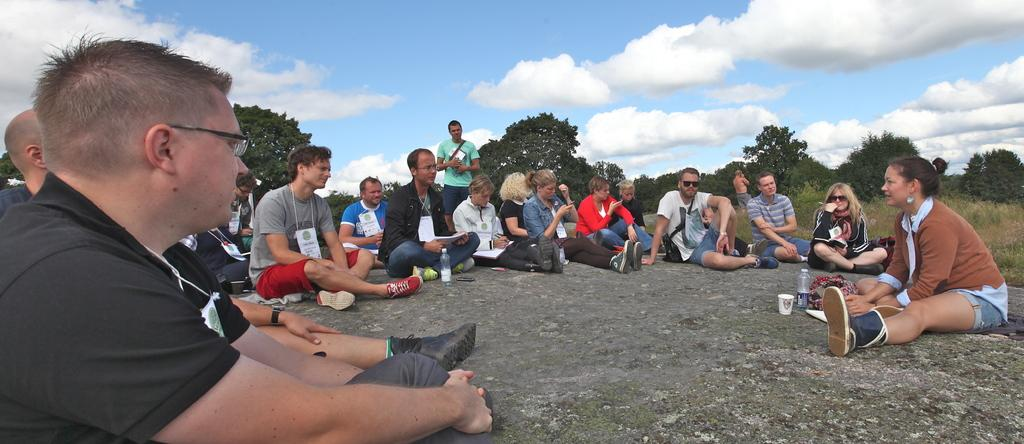What are the people in the image doing? There is a group of people sitting in the image. What type of environment is depicted in the image? There is grass, trees, and the sky visible in the image, suggesting an outdoor setting. What might the people be using to drink in the image? There are glasses and bottles in the image, which could be used for drinking. What type of alley can be seen in the image? There is no alley present in the image. What kind of attraction is depicted in the image? There is no attraction depicted in the image; it shows a group of people sitting in an outdoor setting. 